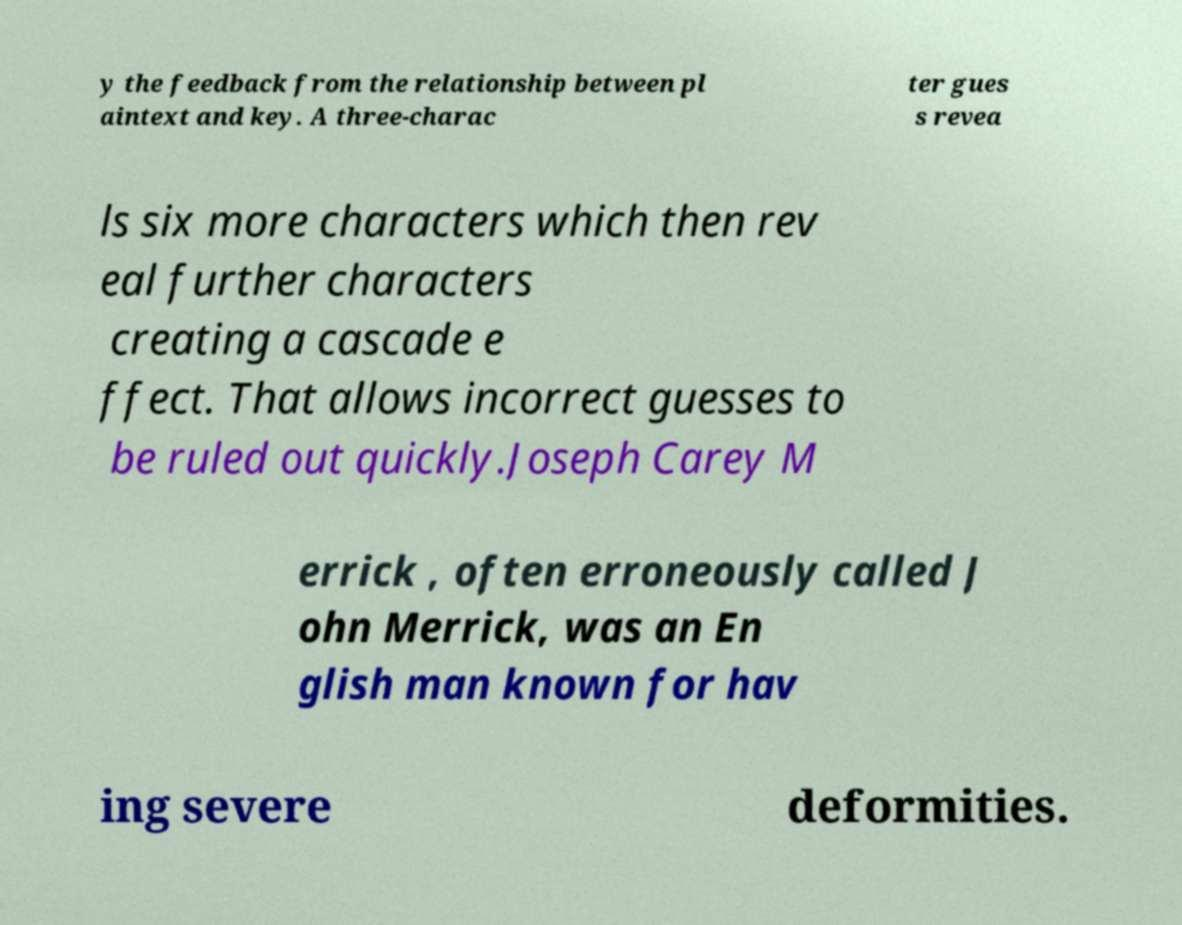I need the written content from this picture converted into text. Can you do that? y the feedback from the relationship between pl aintext and key. A three-charac ter gues s revea ls six more characters which then rev eal further characters creating a cascade e ffect. That allows incorrect guesses to be ruled out quickly.Joseph Carey M errick , often erroneously called J ohn Merrick, was an En glish man known for hav ing severe deformities. 